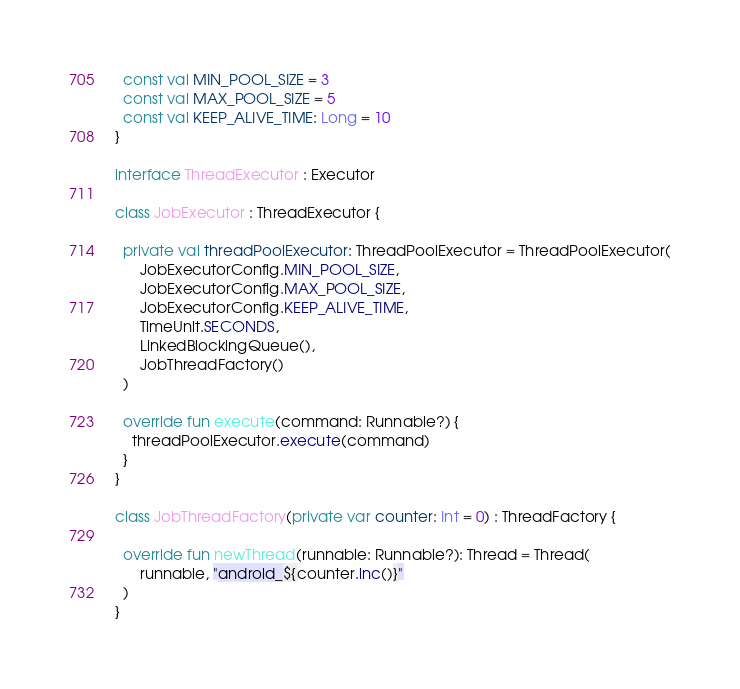Convert code to text. <code><loc_0><loc_0><loc_500><loc_500><_Kotlin_>  const val MIN_POOL_SIZE = 3
  const val MAX_POOL_SIZE = 5
  const val KEEP_ALIVE_TIME: Long = 10
}

interface ThreadExecutor : Executor

class JobExecutor : ThreadExecutor {

  private val threadPoolExecutor: ThreadPoolExecutor = ThreadPoolExecutor(
      JobExecutorConfig.MIN_POOL_SIZE,
      JobExecutorConfig.MAX_POOL_SIZE,
      JobExecutorConfig.KEEP_ALIVE_TIME,
      TimeUnit.SECONDS,
      LinkedBlockingQueue(),
      JobThreadFactory()
  )

  override fun execute(command: Runnable?) {
    threadPoolExecutor.execute(command)
  }
}

class JobThreadFactory(private var counter: Int = 0) : ThreadFactory {

  override fun newThread(runnable: Runnable?): Thread = Thread(
      runnable, "android_${counter.inc()}"
  )
}</code> 